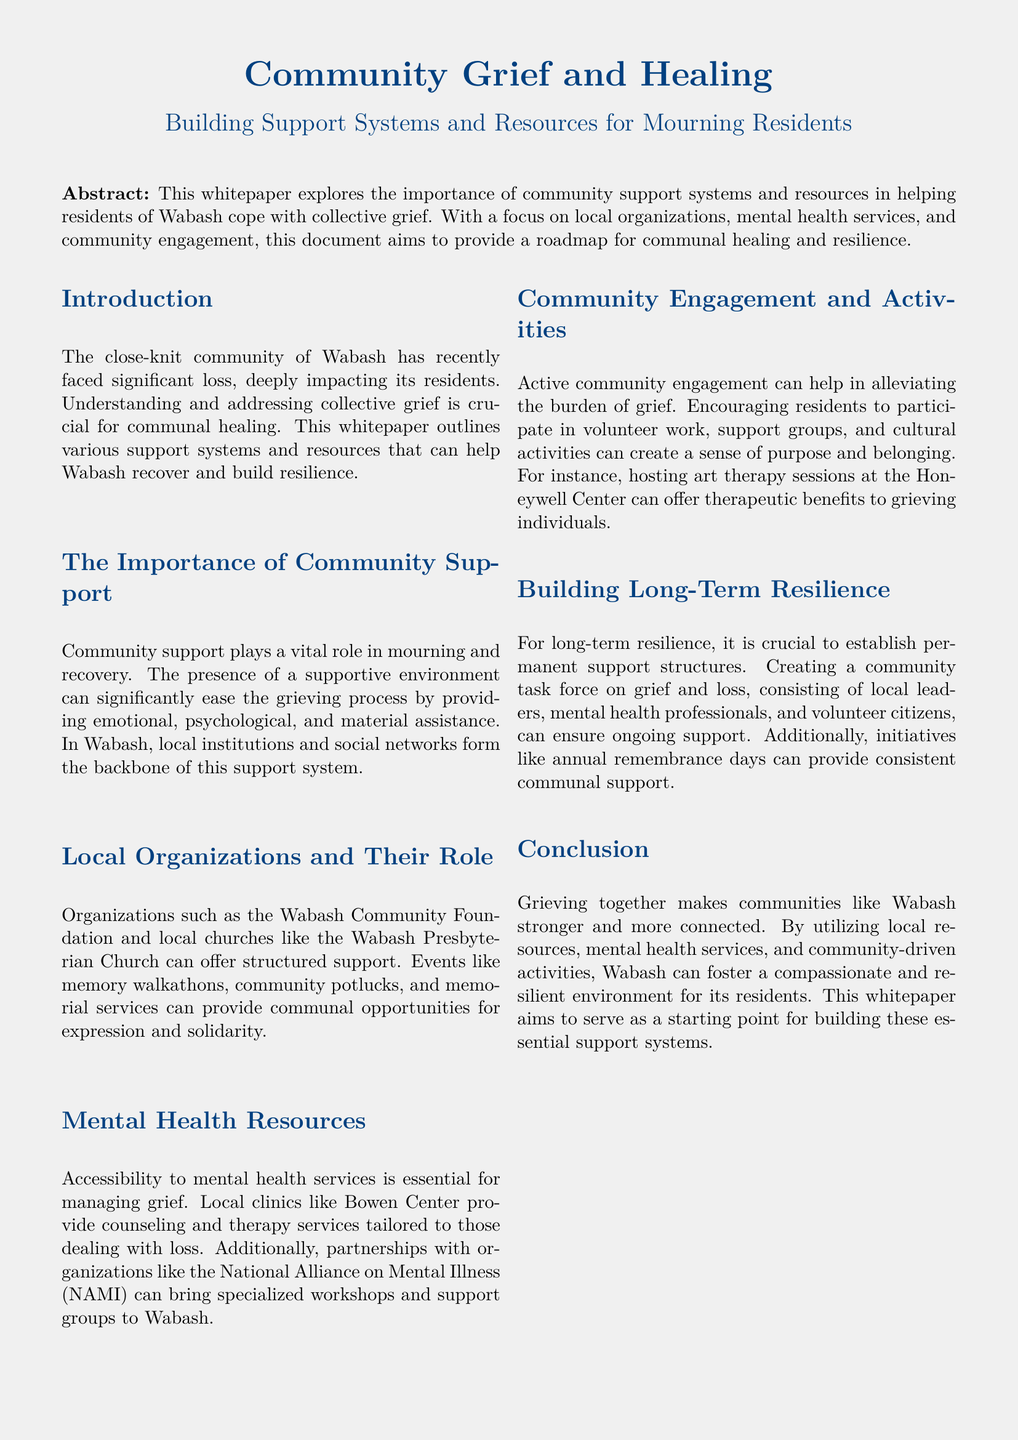What is the title of the whitepaper? The title is mentioned at the top of the document, introducing the main topic being discussed.
Answer: Community Grief and Healing Which organization is mentioned as providing counseling services? The document identifies a specific local clinic that offers mental health support in Wabash.
Answer: Bowen Center What activity is suggested for community engagement? The whitepaper lists several activities aimed at helping residents cope with grief, specifically mentioning one that promotes creativity and therapy.
Answer: Art therapy sessions Who can benefit from attending the workshops mentioned in the document? The document references a specific organization that offers workshops to help those dealing with grief, indicating its audience.
Answer: Grieving individuals What is a key benefit of community support identified in the document? The whitepaper emphasizes one major advantage of having a community support system, particularly during mourning.
Answer: Eases the grieving process What type of support does the Wabash Community Foundation provide? The document describes the organization's role in offering structured support for residents during their grief.
Answer: Structured support Name one event that can help foster community solidarity. The whitepaper lists a specific type of event that brings people together for expression and remembrance.
Answer: Memory walkathons What structure is recommended for long-term resilience? The document advocates for the creation of a specific group that would work on grief and loss within the community.
Answer: Community task force on grief and loss What mental health organization is mentioned for partnerships? The document indicates a collaboration with a well-known organization that specializes in mental health, which could benefit local residents.
Answer: National Alliance on Mental Illness (NAMI) 